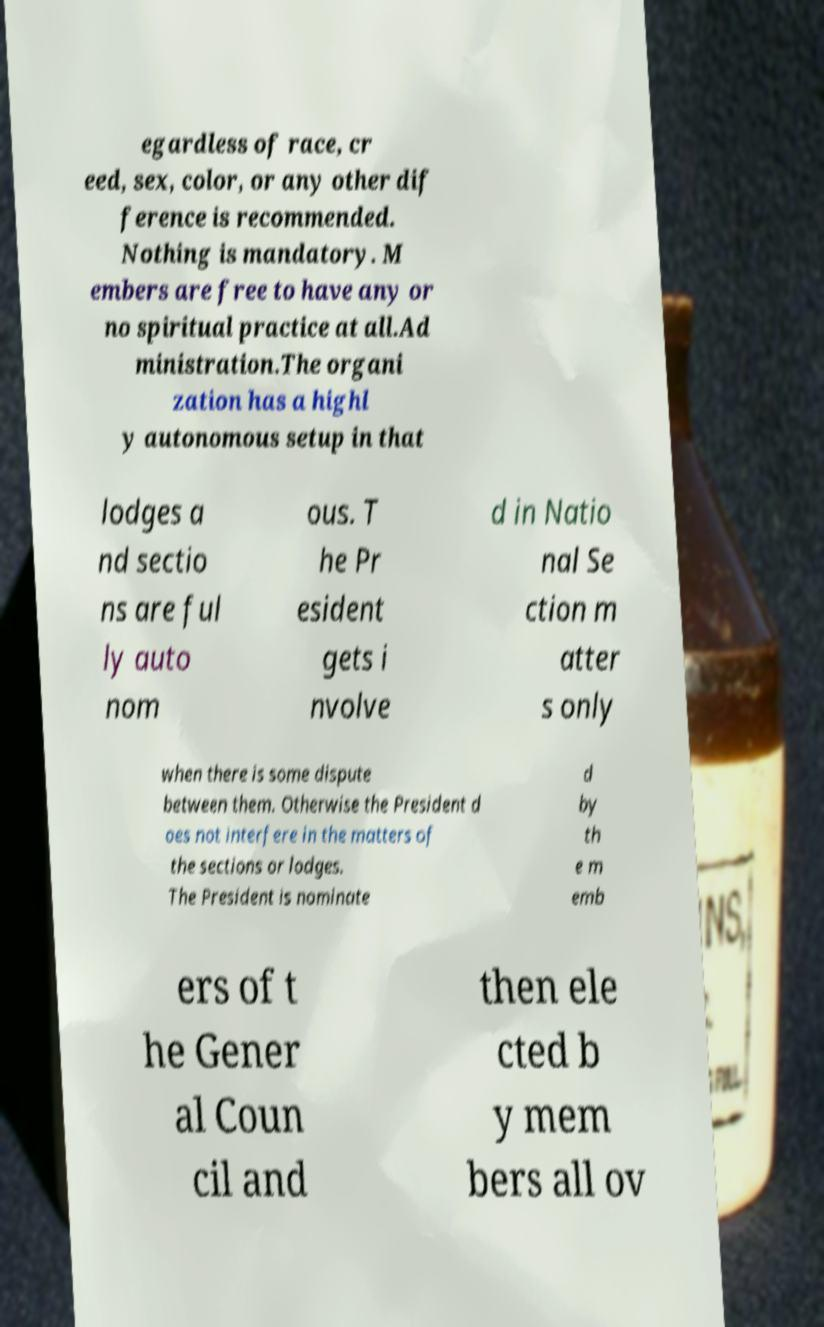Please identify and transcribe the text found in this image. egardless of race, cr eed, sex, color, or any other dif ference is recommended. Nothing is mandatory. M embers are free to have any or no spiritual practice at all.Ad ministration.The organi zation has a highl y autonomous setup in that lodges a nd sectio ns are ful ly auto nom ous. T he Pr esident gets i nvolve d in Natio nal Se ction m atter s only when there is some dispute between them. Otherwise the President d oes not interfere in the matters of the sections or lodges. The President is nominate d by th e m emb ers of t he Gener al Coun cil and then ele cted b y mem bers all ov 